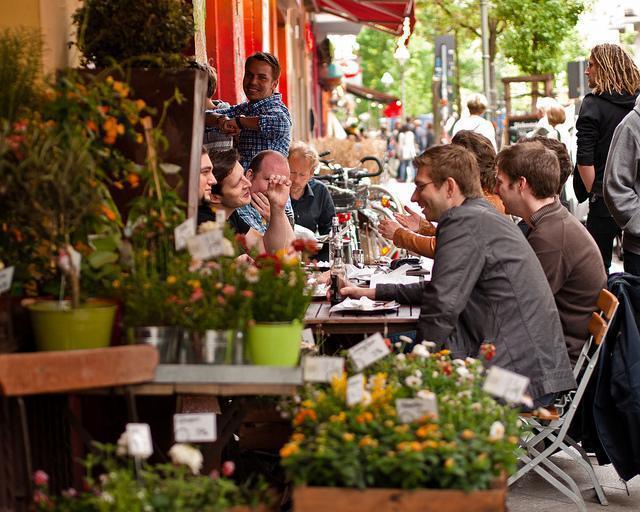How many people are visible?
Give a very brief answer. 8. How many potted plants are in the picture?
Give a very brief answer. 5. 